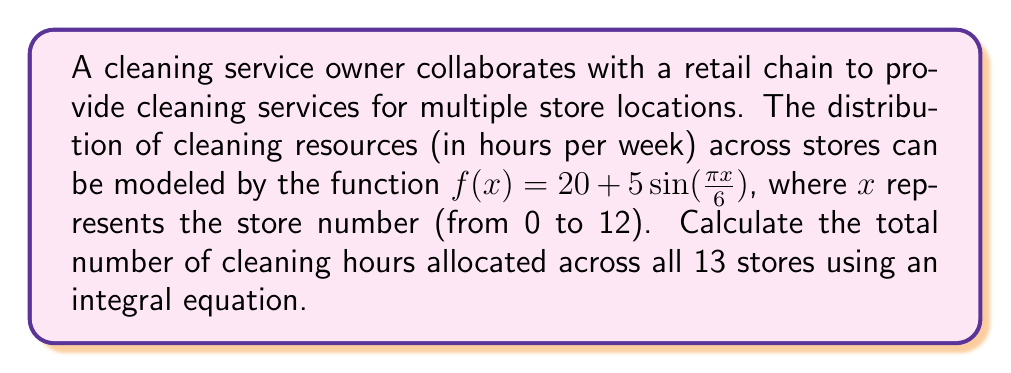Could you help me with this problem? To solve this problem, we need to follow these steps:

1) The function $f(x) = 20 + 5\sin(\frac{\pi x}{6})$ represents the cleaning hours for each store.

2) We need to find the sum of this function for all stores from 0 to 12 (13 stores in total).

3) Instead of adding discrete values, we can use an integral to calculate the area under the curve of $f(x)$ from 0 to 12.

4) The integral equation is:

   $$\int_0^{12} (20 + 5\sin(\frac{\pi x}{6})) dx$$

5) Let's solve this integral:

   $$\int_0^{12} 20 dx + \int_0^{12} 5\sin(\frac{\pi x}{6}) dx$$

6) The first part is straightforward:

   $$20x|_0^{12} = 20 * 12 = 240$$

7) For the second part, we use the substitution method:
   Let $u = \frac{\pi x}{6}$, then $du = \frac{\pi}{6}dx$, or $dx = \frac{6}{\pi}du$

   $$5 * \frac{6}{\pi} \int_0^{2\pi} \sin(u) du = \frac{30}{\pi}[-\cos(u)]_0^{2\pi} = \frac{30}{\pi}[-\cos(2\pi) + \cos(0)] = 0$$

8) Adding the results from steps 6 and 7:

   $$240 + 0 = 240$$
Answer: 240 hours 